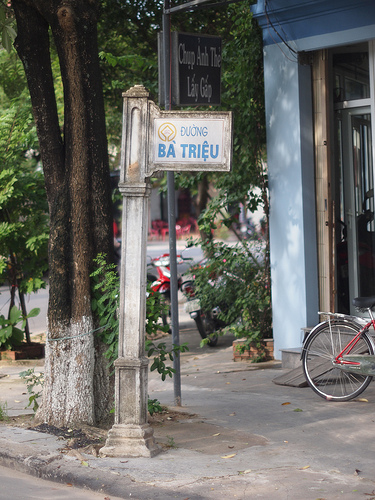Please provide the bounding box coordinate of the region this sentence describes: A wall on the side of a building. The coordinates for the bounding box around the region described as 'a wall on the side of a building' are approximately [0.14, 0.88, 0.3, 0.99]. 